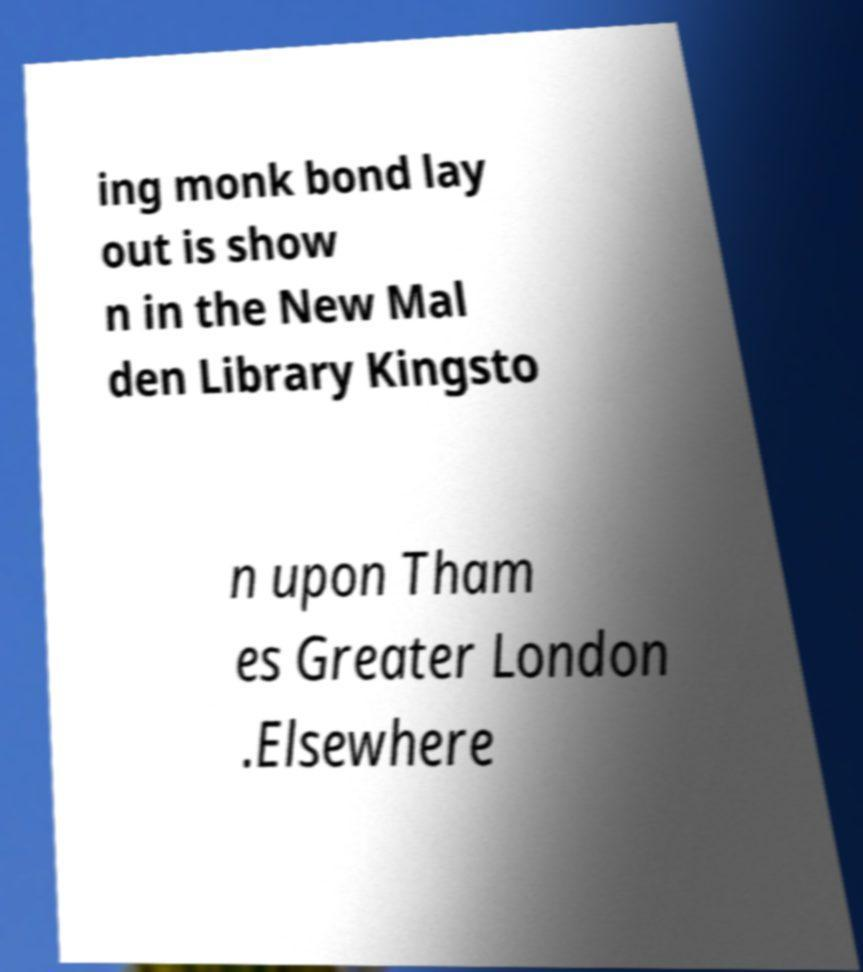Could you assist in decoding the text presented in this image and type it out clearly? ing monk bond lay out is show n in the New Mal den Library Kingsto n upon Tham es Greater London .Elsewhere 